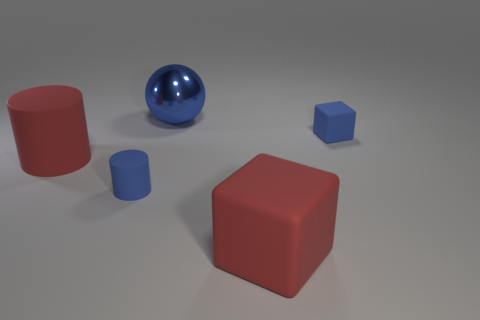Add 5 brown metal blocks. How many objects exist? 10 Subtract all cylinders. How many objects are left? 3 Subtract all big rubber cylinders. Subtract all blue matte things. How many objects are left? 2 Add 3 large metal objects. How many large metal objects are left? 4 Add 2 large yellow spheres. How many large yellow spheres exist? 2 Subtract 1 blue balls. How many objects are left? 4 